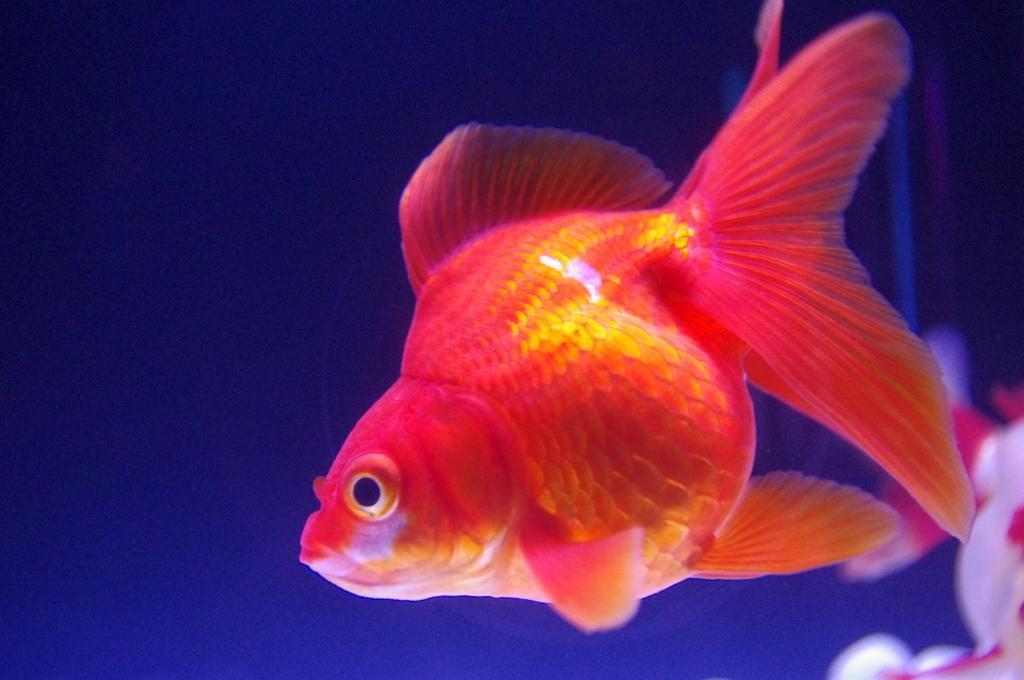In one or two sentences, can you explain what this image depicts? This picture contains an orange fish in the water. Beside that, we see a white and red color fish. In the background, it is blue in color and this picture might be clicked in an aquarium. 